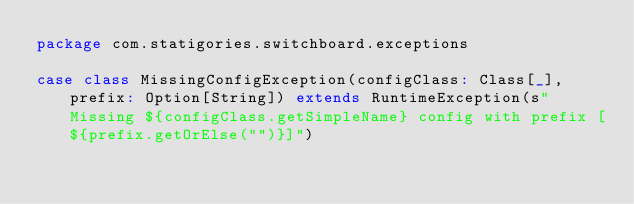<code> <loc_0><loc_0><loc_500><loc_500><_Scala_>package com.statigories.switchboard.exceptions

case class MissingConfigException(configClass: Class[_], prefix: Option[String]) extends RuntimeException(s"Missing ${configClass.getSimpleName} config with prefix [${prefix.getOrElse("")}]")
</code> 